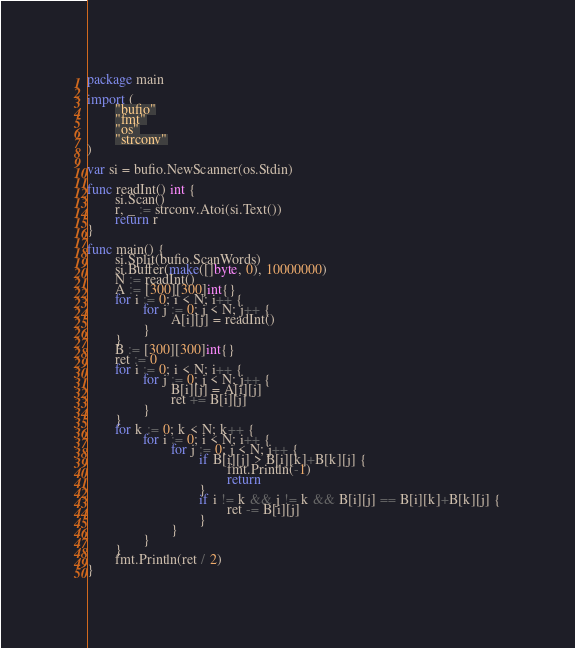Convert code to text. <code><loc_0><loc_0><loc_500><loc_500><_Go_>package main

import (
        "bufio"
        "fmt"
        "os"
        "strconv"
)

var si = bufio.NewScanner(os.Stdin)

func readInt() int {
        si.Scan()
        r, _ := strconv.Atoi(si.Text())
        return r
}

func main() {
        si.Split(bufio.ScanWords)
        si.Buffer(make([]byte, 0), 10000000)
        N := readInt()
        A := [300][300]int{}
        for i := 0; i < N; i++ {
                for j := 0; j < N; j++ {
                        A[i][j] = readInt()
                }
        }
        B := [300][300]int{}
        ret := 0
        for i := 0; i < N; i++ {
                for j := 0; j < N; j++ {
                        B[i][j] = A[i][j]
                        ret += B[i][j]
                }
        }
        for k := 0; k < N; k++ {
                for i := 0; i < N; i++ {
                        for j := 0; j < N; j++ {
                                if B[i][j] > B[i][k]+B[k][j] {
                                        fmt.Println(-1)
                                        return
                                }
                                if i != k && j != k && B[i][j] == B[i][k]+B[k][j] {
                                        ret -= B[i][j]
                                }
                        }
                }
        }
        fmt.Println(ret / 2)
}</code> 